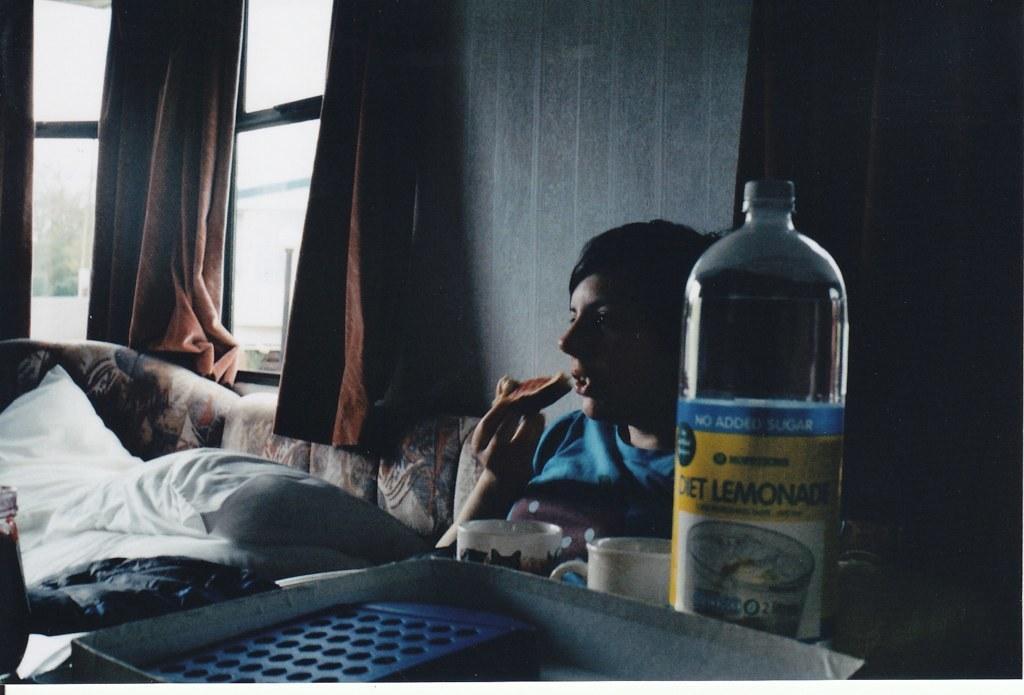Describe this image in one or two sentences. In this picture we can see men sitting on sofa and eating bread and in front of him we can see cup, bottle, tray and beside to him we have curtains to window, pillows on sofa. 